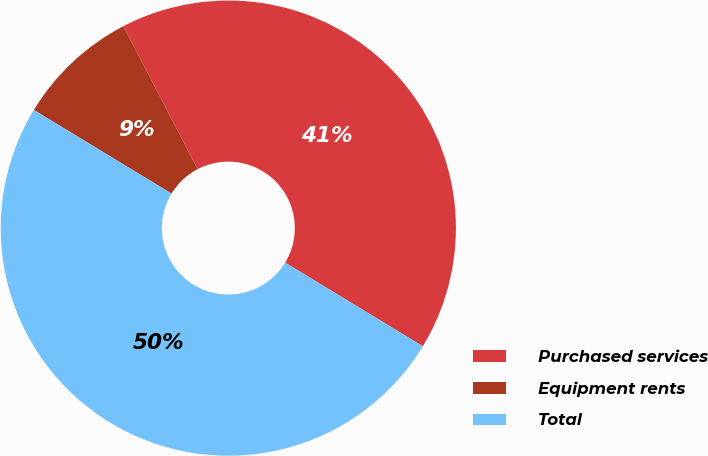<chart> <loc_0><loc_0><loc_500><loc_500><pie_chart><fcel>Purchased services<fcel>Equipment rents<fcel>Total<nl><fcel>41.32%<fcel>8.68%<fcel>50.0%<nl></chart> 